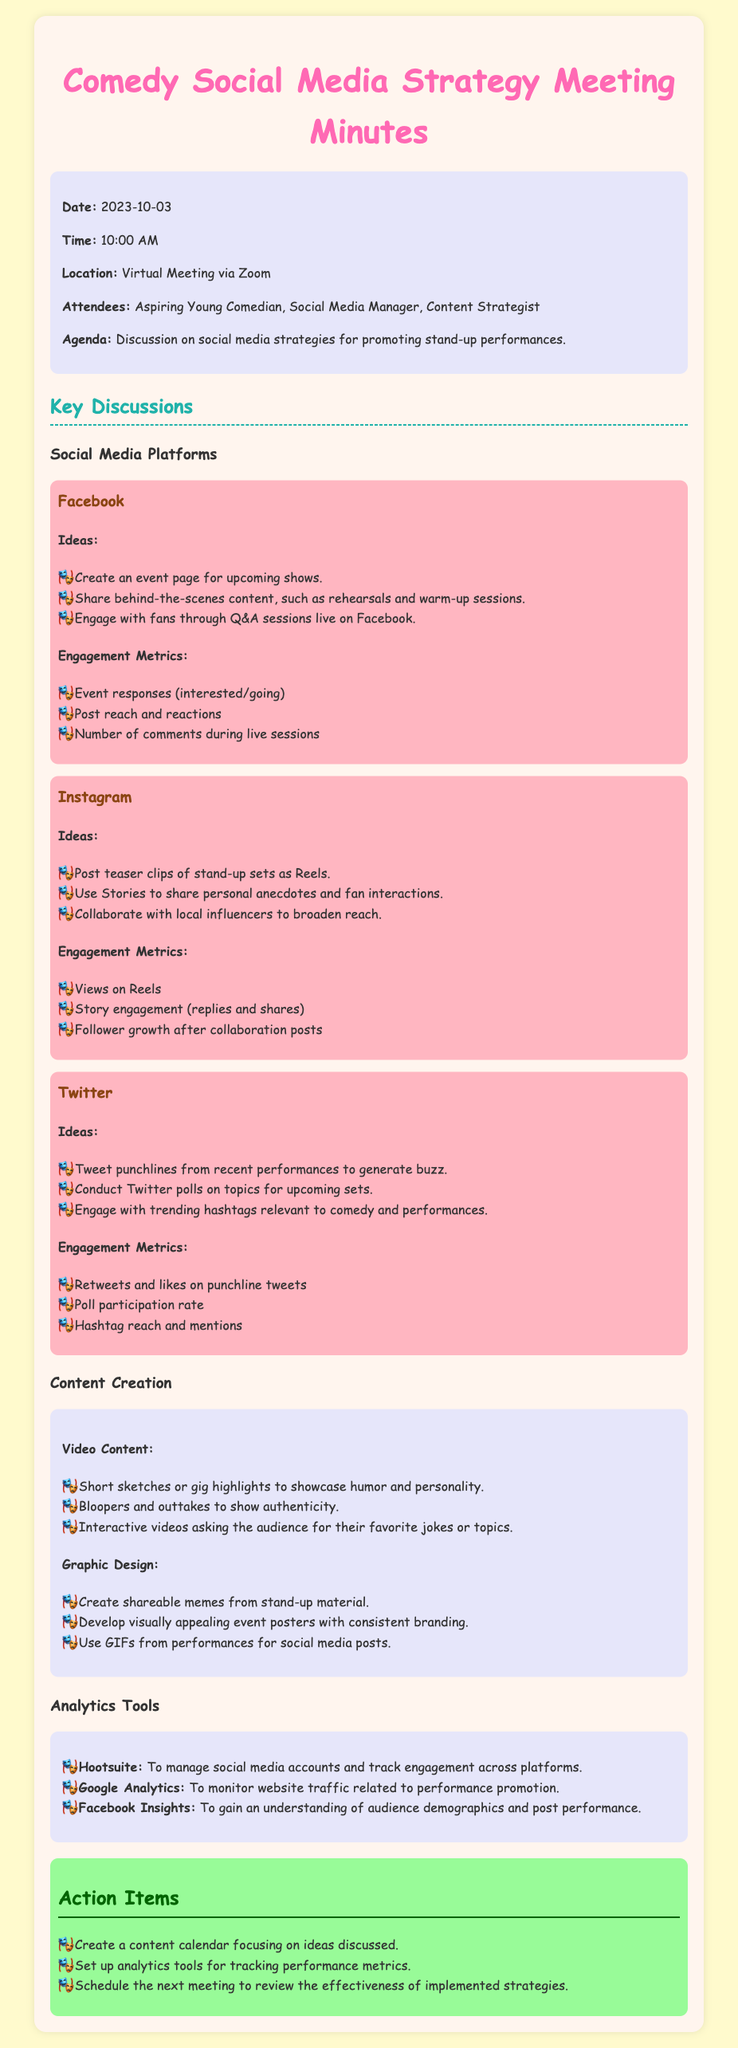what date was the meeting held? The date of the meeting is mentioned in the info box at the top of the document.
Answer: 2023-10-03 who attended the meeting? The attendees are listed in the info box, specifying who was present during the meeting.
Answer: Aspiring Young Comedian, Social Media Manager, Content Strategist which social media platform suggests creating event pages? The document provides a list of ideas for each social media platform, which includes details about Facebook.
Answer: Facebook what is one engagement metric for Instagram? The engagement metrics for Instagram are listed under the Instagram platform section.
Answer: Story engagement (replies and shares) how many action items are listed in the document? The action items are outlined in a specific section of the document, which indicates how many were identified.
Answer: 3 what type of content is recommended for Twitter? The ideas section for Twitter includes specific content suggestions that are based on engagement strategies.
Answer: Tweet punchlines from recent performances which tool is suggested for managing social media accounts? The analytics tools section specifies which tools can be utilized for effective social media management.
Answer: Hootsuite what was the purpose of the meeting? The purpose is articulated in the agenda section, summarizing the main focus of the meeting.
Answer: Discussion on social media strategies for promoting stand-up performances 